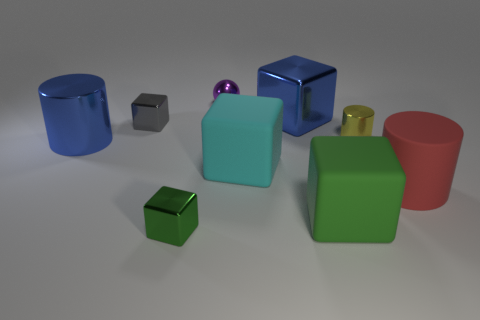Can you describe the texture of the objects? Certainly, all the objects in the image appear to have a smooth texture, with reflective surfaces that suggest a metallic or plastic material. The metal ball, in particular, has a highly reflective, almost mirror-like finish, while the cubes and cylinders have a slightly matte, but still reflective, surface. 